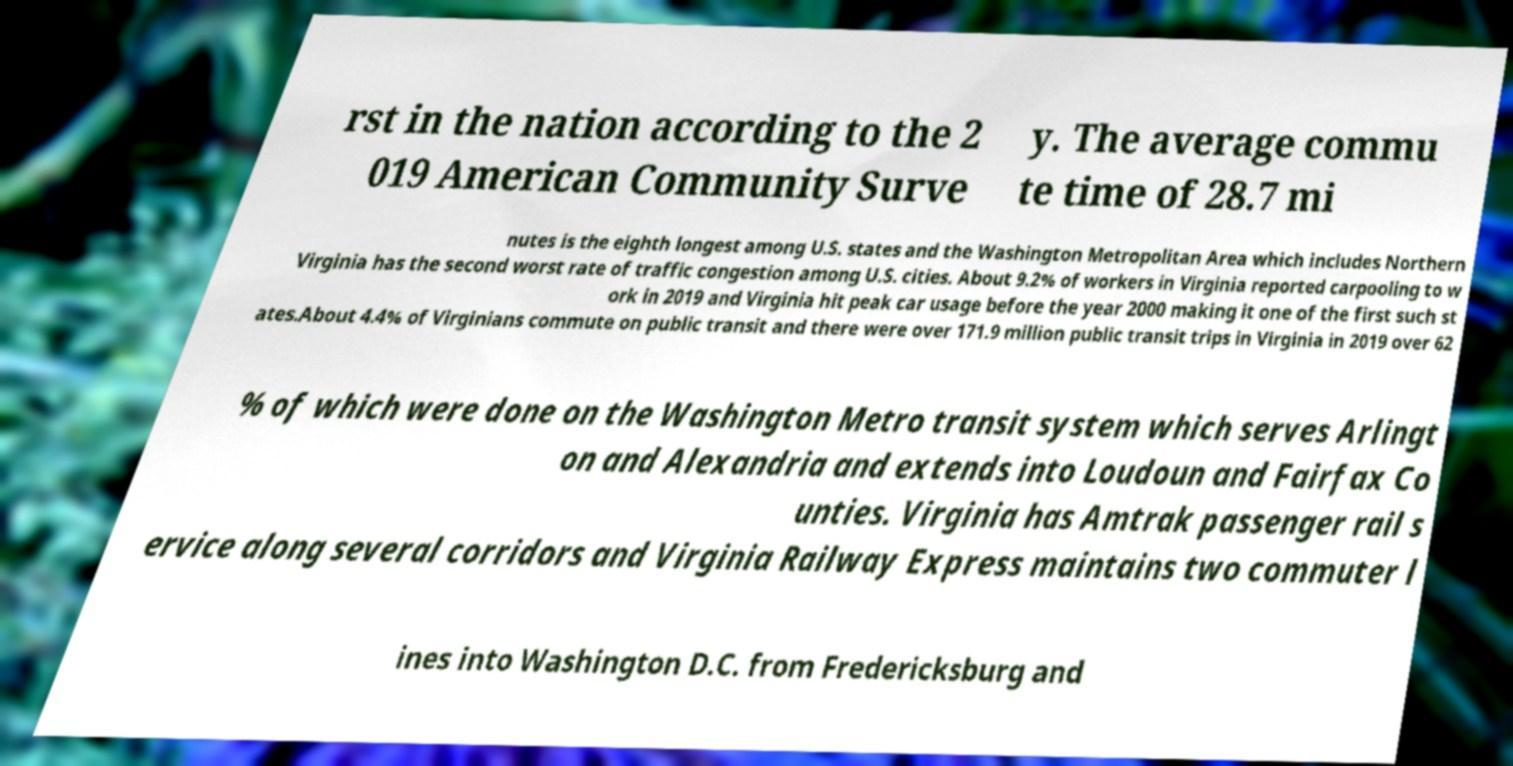Please read and relay the text visible in this image. What does it say? rst in the nation according to the 2 019 American Community Surve y. The average commu te time of 28.7 mi nutes is the eighth longest among U.S. states and the Washington Metropolitan Area which includes Northern Virginia has the second worst rate of traffic congestion among U.S. cities. About 9.2% of workers in Virginia reported carpooling to w ork in 2019 and Virginia hit peak car usage before the year 2000 making it one of the first such st ates.About 4.4% of Virginians commute on public transit and there were over 171.9 million public transit trips in Virginia in 2019 over 62 % of which were done on the Washington Metro transit system which serves Arlingt on and Alexandria and extends into Loudoun and Fairfax Co unties. Virginia has Amtrak passenger rail s ervice along several corridors and Virginia Railway Express maintains two commuter l ines into Washington D.C. from Fredericksburg and 